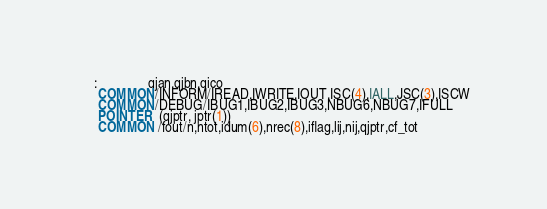<code> <loc_0><loc_0><loc_500><loc_500><_FORTRAN_>     :               qjan,qjbn,qico
      COMMON/INFORM/IREAD,IWRITE,IOUT,ISC(4),IALL,JSC(3),ISCW
      COMMON/DEBUG/IBUG1,IBUG2,IBUG3,NBUG6,NBUG7,IFULL
      POINTER  (qjptr, jptr(1))
      COMMON /fout/n,ntot,idum(6),nrec(8),iflag,lij,nij,qjptr,cf_tot</code> 